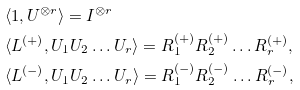Convert formula to latex. <formula><loc_0><loc_0><loc_500><loc_500>& \langle 1 , U ^ { \otimes r } \rangle = I ^ { \otimes r } \\ & \langle L ^ { ( + ) } , U _ { 1 } U _ { 2 } \dots U _ { r } \rangle = R _ { 1 } ^ { ( + ) } R _ { 2 } ^ { ( + ) } \dots R _ { r } ^ { ( + ) } , \\ & \langle L ^ { ( - ) } , U _ { 1 } U _ { 2 } \dots U _ { r } \rangle = R _ { 1 } ^ { ( - ) } R _ { 2 } ^ { ( - ) } \dots R _ { r } ^ { ( - ) } ,</formula> 